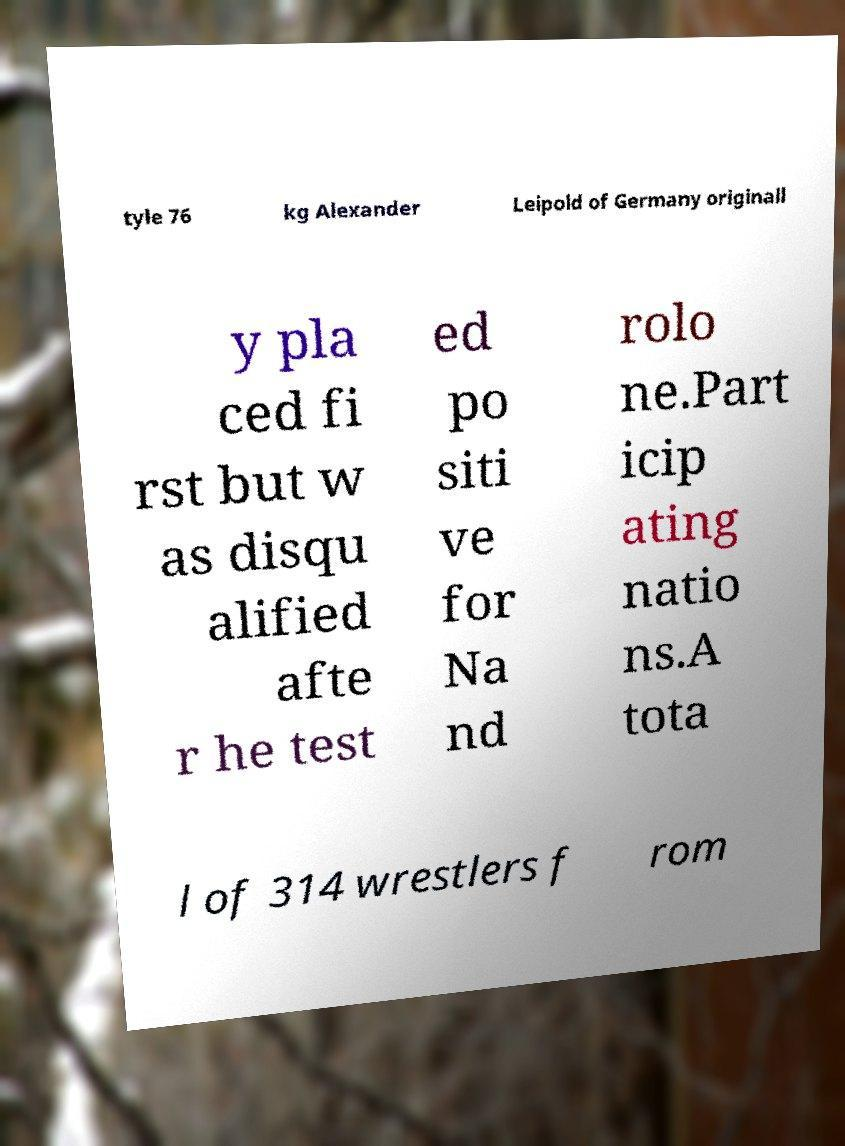Can you accurately transcribe the text from the provided image for me? tyle 76 kg Alexander Leipold of Germany originall y pla ced fi rst but w as disqu alified afte r he test ed po siti ve for Na nd rolo ne.Part icip ating natio ns.A tota l of 314 wrestlers f rom 